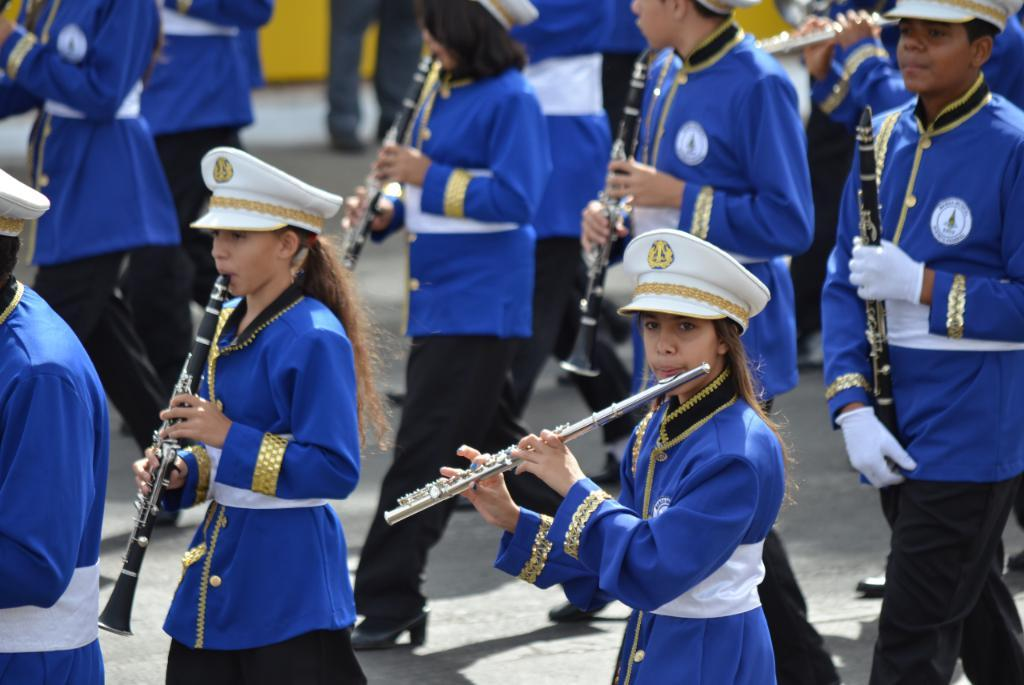What is the main subject of the image? The main subject of the image is a group of people. What are the people wearing in the image? The people are wearing blue color dresses. What are the people doing in the image? The people are playing musical instruments. How many lizards are hidden in the image? There are no lizards present in the image. What type of riddle can be solved by looking at the image? There is no riddle associated with the image, as it simply depicts a group of people playing musical instruments. 